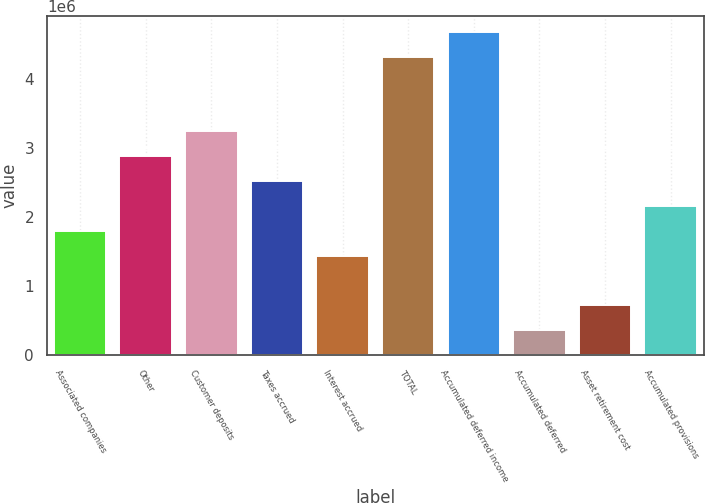Convert chart. <chart><loc_0><loc_0><loc_500><loc_500><bar_chart><fcel>Associated companies<fcel>Other<fcel>Customer deposits<fcel>Taxes accrued<fcel>Interest accrued<fcel>TOTAL<fcel>Accumulated deferred income<fcel>Accumulated deferred<fcel>Asset retirement cost<fcel>Accumulated provisions<nl><fcel>1.80115e+06<fcel>2.88175e+06<fcel>3.24194e+06<fcel>2.52155e+06<fcel>1.44096e+06<fcel>4.32253e+06<fcel>4.68273e+06<fcel>360364<fcel>720562<fcel>2.16135e+06<nl></chart> 